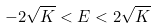Convert formula to latex. <formula><loc_0><loc_0><loc_500><loc_500>- 2 \sqrt { K } < E < 2 \sqrt { K }</formula> 